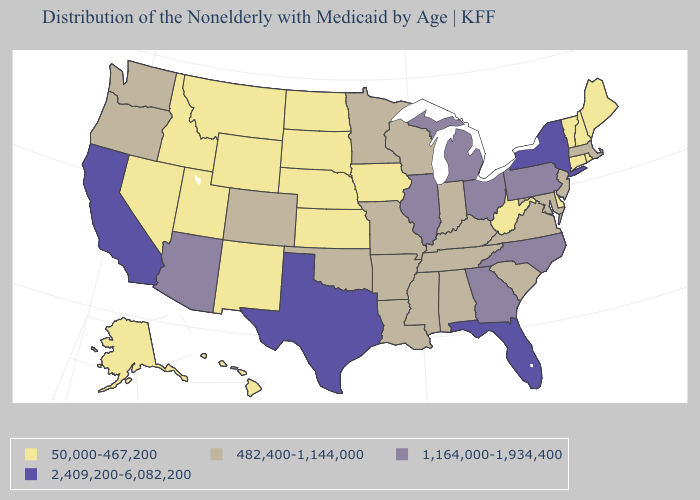What is the lowest value in the South?
Give a very brief answer. 50,000-467,200. Which states have the lowest value in the Northeast?
Concise answer only. Connecticut, Maine, New Hampshire, Rhode Island, Vermont. Name the states that have a value in the range 2,409,200-6,082,200?
Give a very brief answer. California, Florida, New York, Texas. Which states have the lowest value in the USA?
Quick response, please. Alaska, Connecticut, Delaware, Hawaii, Idaho, Iowa, Kansas, Maine, Montana, Nebraska, Nevada, New Hampshire, New Mexico, North Dakota, Rhode Island, South Dakota, Utah, Vermont, West Virginia, Wyoming. What is the value of Delaware?
Short answer required. 50,000-467,200. Among the states that border Montana , which have the lowest value?
Short answer required. Idaho, North Dakota, South Dakota, Wyoming. How many symbols are there in the legend?
Write a very short answer. 4. Does the first symbol in the legend represent the smallest category?
Quick response, please. Yes. Name the states that have a value in the range 482,400-1,144,000?
Keep it brief. Alabama, Arkansas, Colorado, Indiana, Kentucky, Louisiana, Maryland, Massachusetts, Minnesota, Mississippi, Missouri, New Jersey, Oklahoma, Oregon, South Carolina, Tennessee, Virginia, Washington, Wisconsin. What is the value of South Carolina?
Concise answer only. 482,400-1,144,000. Does the map have missing data?
Keep it brief. No. Is the legend a continuous bar?
Be succinct. No. Which states have the highest value in the USA?
Keep it brief. California, Florida, New York, Texas. What is the value of Pennsylvania?
Concise answer only. 1,164,000-1,934,400. Does Texas have the lowest value in the USA?
Quick response, please. No. 